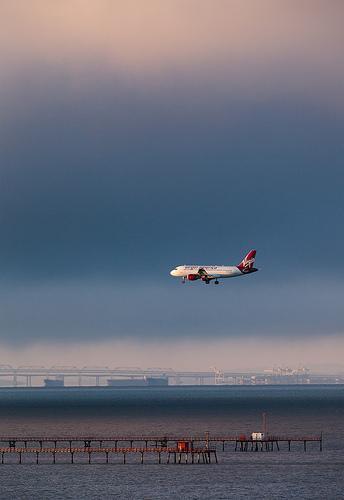How many planes can be seen?
Give a very brief answer. 1. 